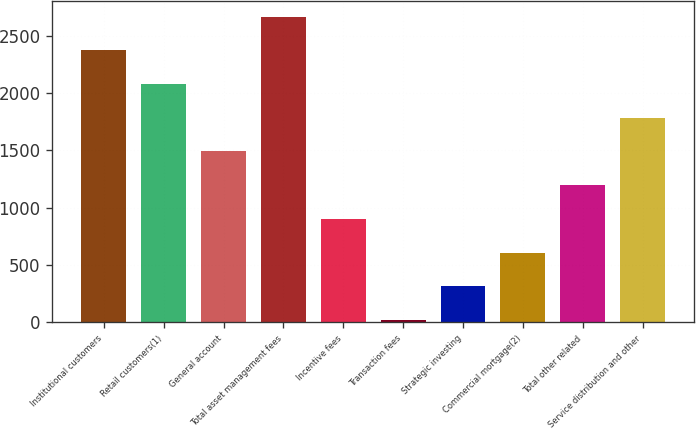Convert chart. <chart><loc_0><loc_0><loc_500><loc_500><bar_chart><fcel>Institutional customers<fcel>Retail customers(1)<fcel>General account<fcel>Total asset management fees<fcel>Incentive fees<fcel>Transaction fees<fcel>Strategic investing<fcel>Commercial mortgage(2)<fcel>Total other related<fcel>Service distribution and other<nl><fcel>2372.6<fcel>2078.4<fcel>1490<fcel>2666.8<fcel>901.6<fcel>19<fcel>313.2<fcel>607.4<fcel>1195.8<fcel>1784.2<nl></chart> 